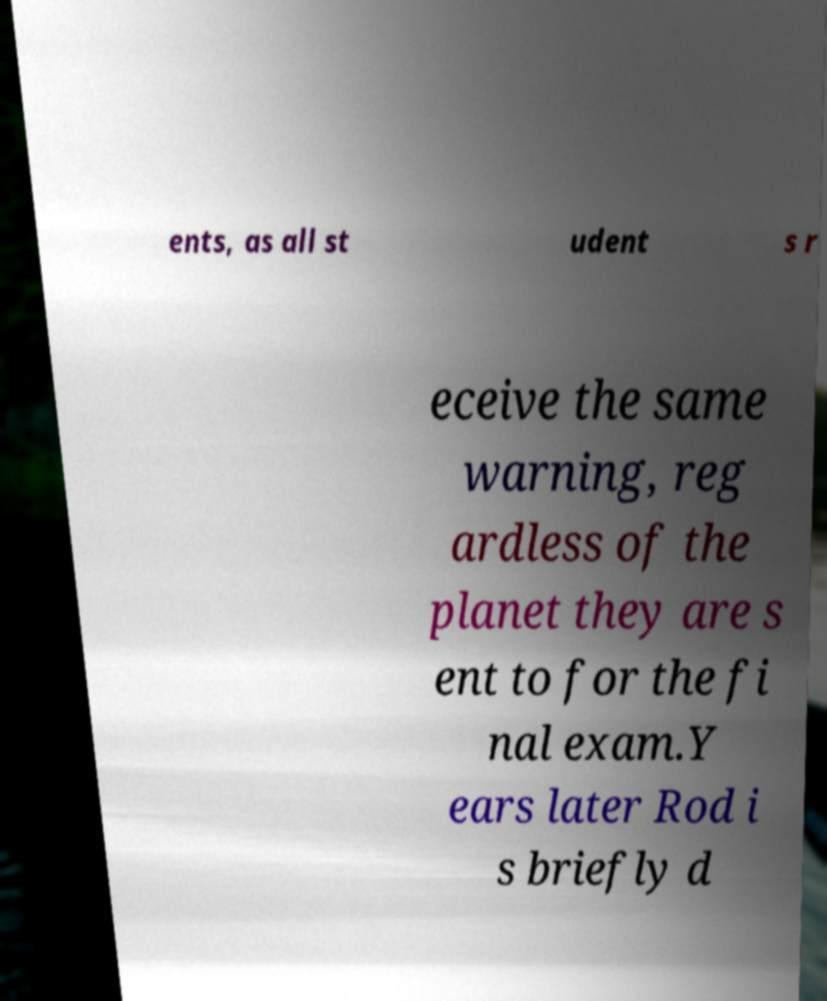Can you accurately transcribe the text from the provided image for me? ents, as all st udent s r eceive the same warning, reg ardless of the planet they are s ent to for the fi nal exam.Y ears later Rod i s briefly d 